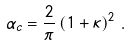<formula> <loc_0><loc_0><loc_500><loc_500>\alpha _ { c } = \frac { 2 } { \pi } \left ( 1 + \kappa \right ) ^ { 2 } \, .</formula> 